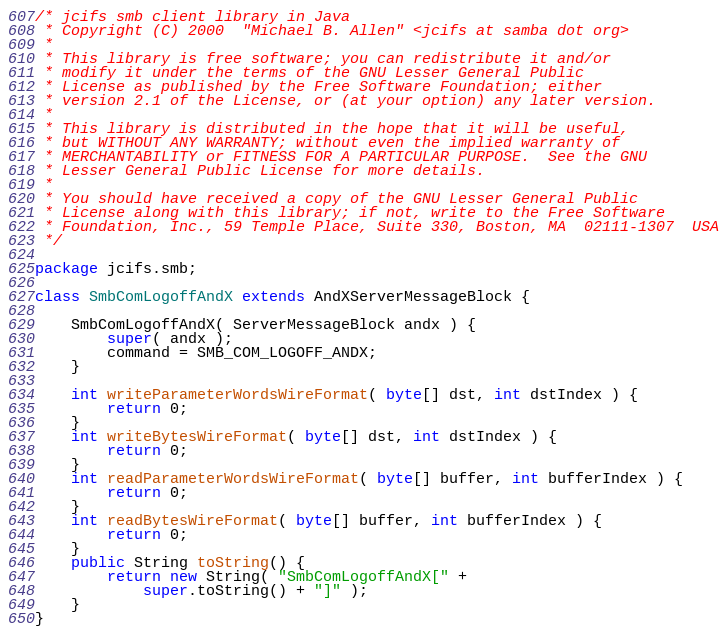Convert code to text. <code><loc_0><loc_0><loc_500><loc_500><_Java_>/* jcifs smb client library in Java
 * Copyright (C) 2000  "Michael B. Allen" <jcifs at samba dot org>
 * 
 * This library is free software; you can redistribute it and/or
 * modify it under the terms of the GNU Lesser General Public
 * License as published by the Free Software Foundation; either
 * version 2.1 of the License, or (at your option) any later version.
 * 
 * This library is distributed in the hope that it will be useful,
 * but WITHOUT ANY WARRANTY; without even the implied warranty of
 * MERCHANTABILITY or FITNESS FOR A PARTICULAR PURPOSE.  See the GNU
 * Lesser General Public License for more details.
 * 
 * You should have received a copy of the GNU Lesser General Public
 * License along with this library; if not, write to the Free Software
 * Foundation, Inc., 59 Temple Place, Suite 330, Boston, MA  02111-1307  USA
 */

package jcifs.smb;

class SmbComLogoffAndX extends AndXServerMessageBlock {

    SmbComLogoffAndX( ServerMessageBlock andx ) {
        super( andx );
        command = SMB_COM_LOGOFF_ANDX;
    }

    int writeParameterWordsWireFormat( byte[] dst, int dstIndex ) {
        return 0;
    }
    int writeBytesWireFormat( byte[] dst, int dstIndex ) {
        return 0;
    }
    int readParameterWordsWireFormat( byte[] buffer, int bufferIndex ) {
        return 0;
    }
    int readBytesWireFormat( byte[] buffer, int bufferIndex ) {
        return 0;
    }
    public String toString() {
        return new String( "SmbComLogoffAndX[" +
            super.toString() + "]" );
    }
}
</code> 